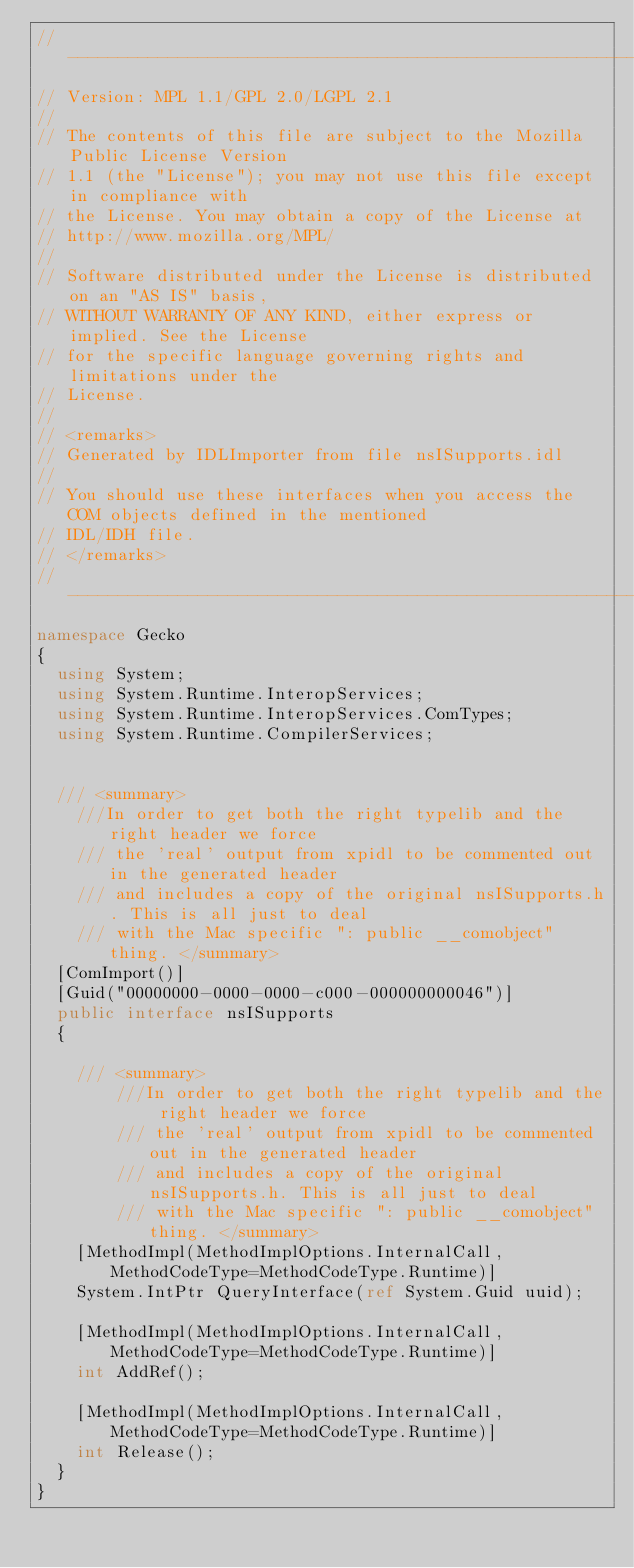<code> <loc_0><loc_0><loc_500><loc_500><_C#_>// --------------------------------------------------------------------------------------------
// Version: MPL 1.1/GPL 2.0/LGPL 2.1
// 
// The contents of this file are subject to the Mozilla Public License Version
// 1.1 (the "License"); you may not use this file except in compliance with
// the License. You may obtain a copy of the License at
// http://www.mozilla.org/MPL/
// 
// Software distributed under the License is distributed on an "AS IS" basis,
// WITHOUT WARRANTY OF ANY KIND, either express or implied. See the License
// for the specific language governing rights and limitations under the
// License.
// 
// <remarks>
// Generated by IDLImporter from file nsISupports.idl
// 
// You should use these interfaces when you access the COM objects defined in the mentioned
// IDL/IDH file.
// </remarks>
// --------------------------------------------------------------------------------------------
namespace Gecko
{
	using System;
	using System.Runtime.InteropServices;
	using System.Runtime.InteropServices.ComTypes;
	using System.Runtime.CompilerServices;
	
	
	/// <summary>
    ///In order to get both the right typelib and the right header we force
    /// the 'real' output from xpidl to be commented out in the generated header
    /// and includes a copy of the original nsISupports.h. This is all just to deal
    /// with the Mac specific ": public __comobject" thing. </summary>
	[ComImport()]
	[Guid("00000000-0000-0000-c000-000000000046")]
	public interface nsISupports
	{
		
		/// <summary>
        ///In order to get both the right typelib and the right header we force
        /// the 'real' output from xpidl to be commented out in the generated header
        /// and includes a copy of the original nsISupports.h. This is all just to deal
        /// with the Mac specific ": public __comobject" thing. </summary>
		[MethodImpl(MethodImplOptions.InternalCall, MethodCodeType=MethodCodeType.Runtime)]
		System.IntPtr QueryInterface(ref System.Guid uuid);
		
		[MethodImpl(MethodImplOptions.InternalCall, MethodCodeType=MethodCodeType.Runtime)]
		int AddRef();
		
		[MethodImpl(MethodImplOptions.InternalCall, MethodCodeType=MethodCodeType.Runtime)]
		int Release();
	}
}
</code> 